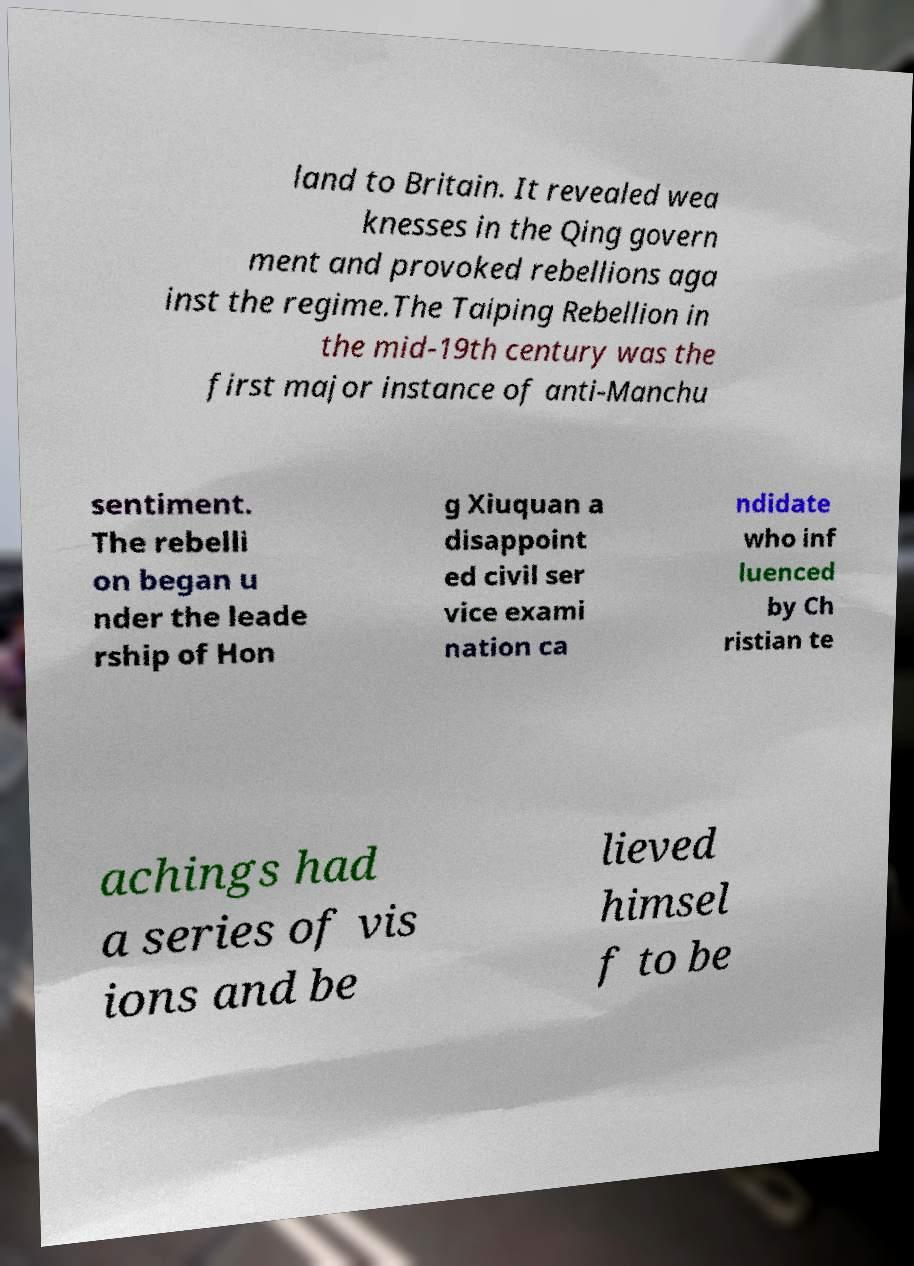Please identify and transcribe the text found in this image. land to Britain. It revealed wea knesses in the Qing govern ment and provoked rebellions aga inst the regime.The Taiping Rebellion in the mid-19th century was the first major instance of anti-Manchu sentiment. The rebelli on began u nder the leade rship of Hon g Xiuquan a disappoint ed civil ser vice exami nation ca ndidate who inf luenced by Ch ristian te achings had a series of vis ions and be lieved himsel f to be 